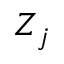Convert formula to latex. <formula><loc_0><loc_0><loc_500><loc_500>Z _ { j }</formula> 